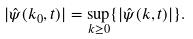<formula> <loc_0><loc_0><loc_500><loc_500>| \hat { \psi } ( k _ { 0 } , t ) | = \sup _ { k \geq 0 } \{ | \hat { \psi } ( k , t ) | \} .</formula> 